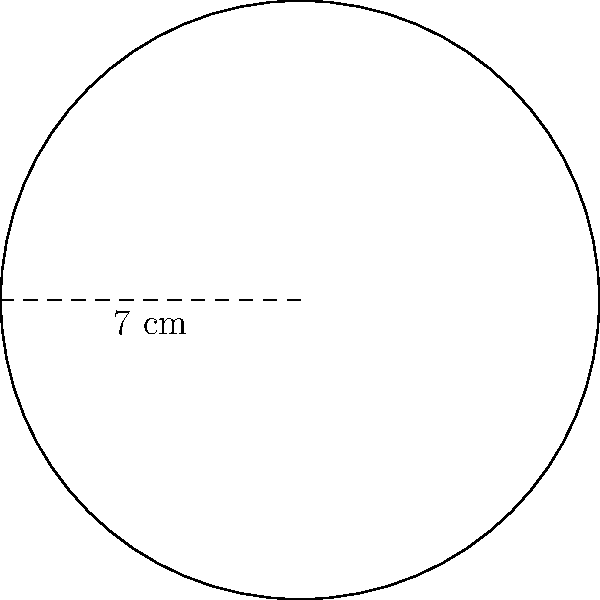In the dessert-making workshop, you're using a circular cake pan. If the radius of the pan is 7 cm, what is the area of the cake you can make? To find the area of a circular cake pan, we need to use the formula for the area of a circle:

$$A = \pi r^2$$

Where:
$A$ is the area
$\pi$ (pi) is approximately 3.14159
$r$ is the radius of the circle

Given:
Radius ($r$) = 7 cm

Step 1: Substitute the radius into the formula
$$A = \pi (7 \text{ cm})^2$$

Step 2: Calculate the square of the radius
$$A = \pi (49 \text{ cm}^2)$$

Step 3: Multiply by π
$$A = 153.94 \text{ cm}^2$$ (rounded to two decimal places)

Therefore, the area of the cake you can make is approximately 153.94 square centimeters.
Answer: 153.94 cm² 